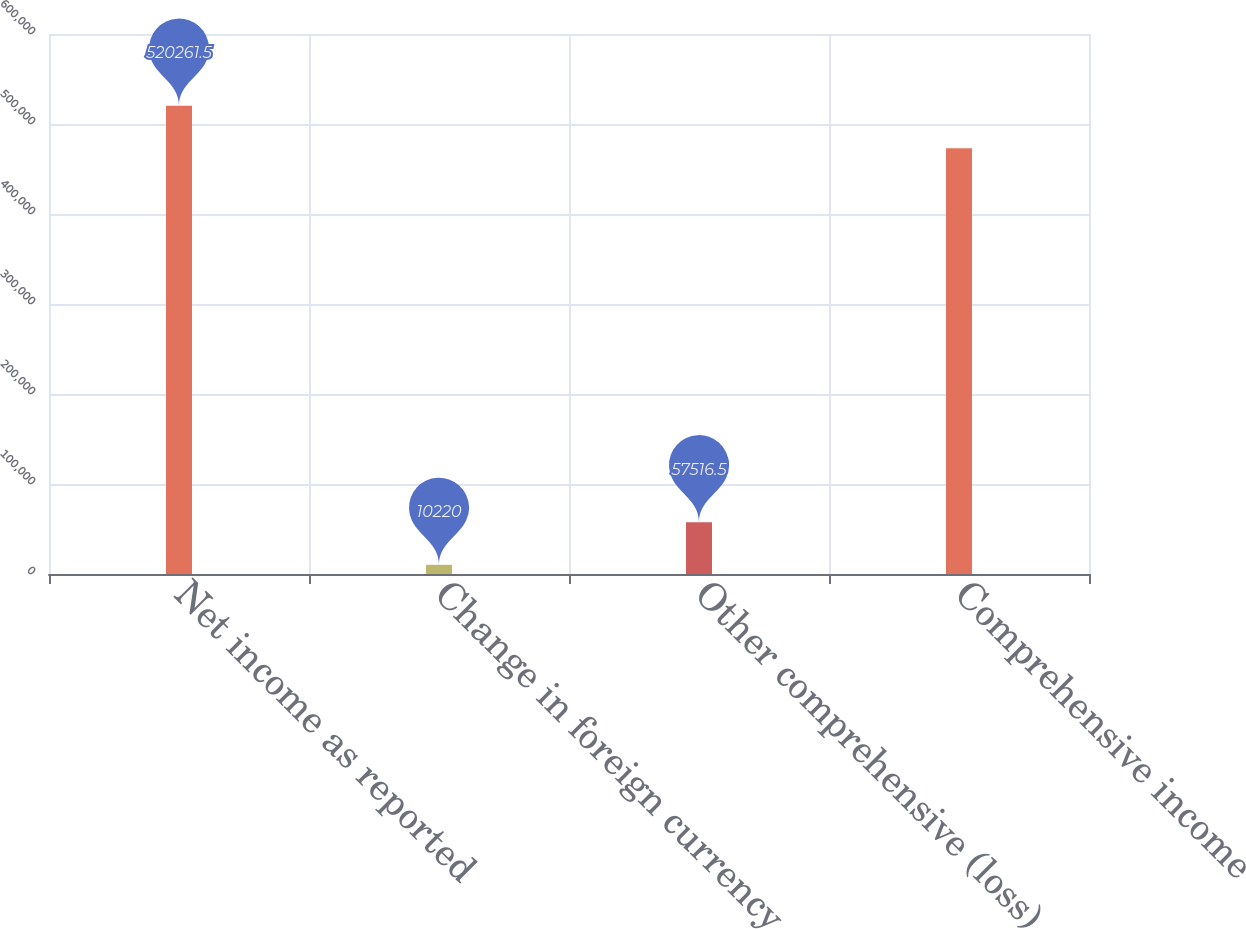<chart> <loc_0><loc_0><loc_500><loc_500><bar_chart><fcel>Net income as reported<fcel>Change in foreign currency<fcel>Other comprehensive (loss)<fcel>Comprehensive income<nl><fcel>520262<fcel>10220<fcel>57516.5<fcel>472965<nl></chart> 